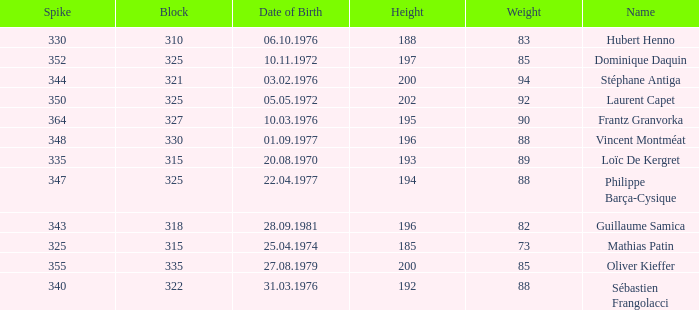How many spikes have 28.09.1981 as the date of birth, with a block greater than 318? None. 